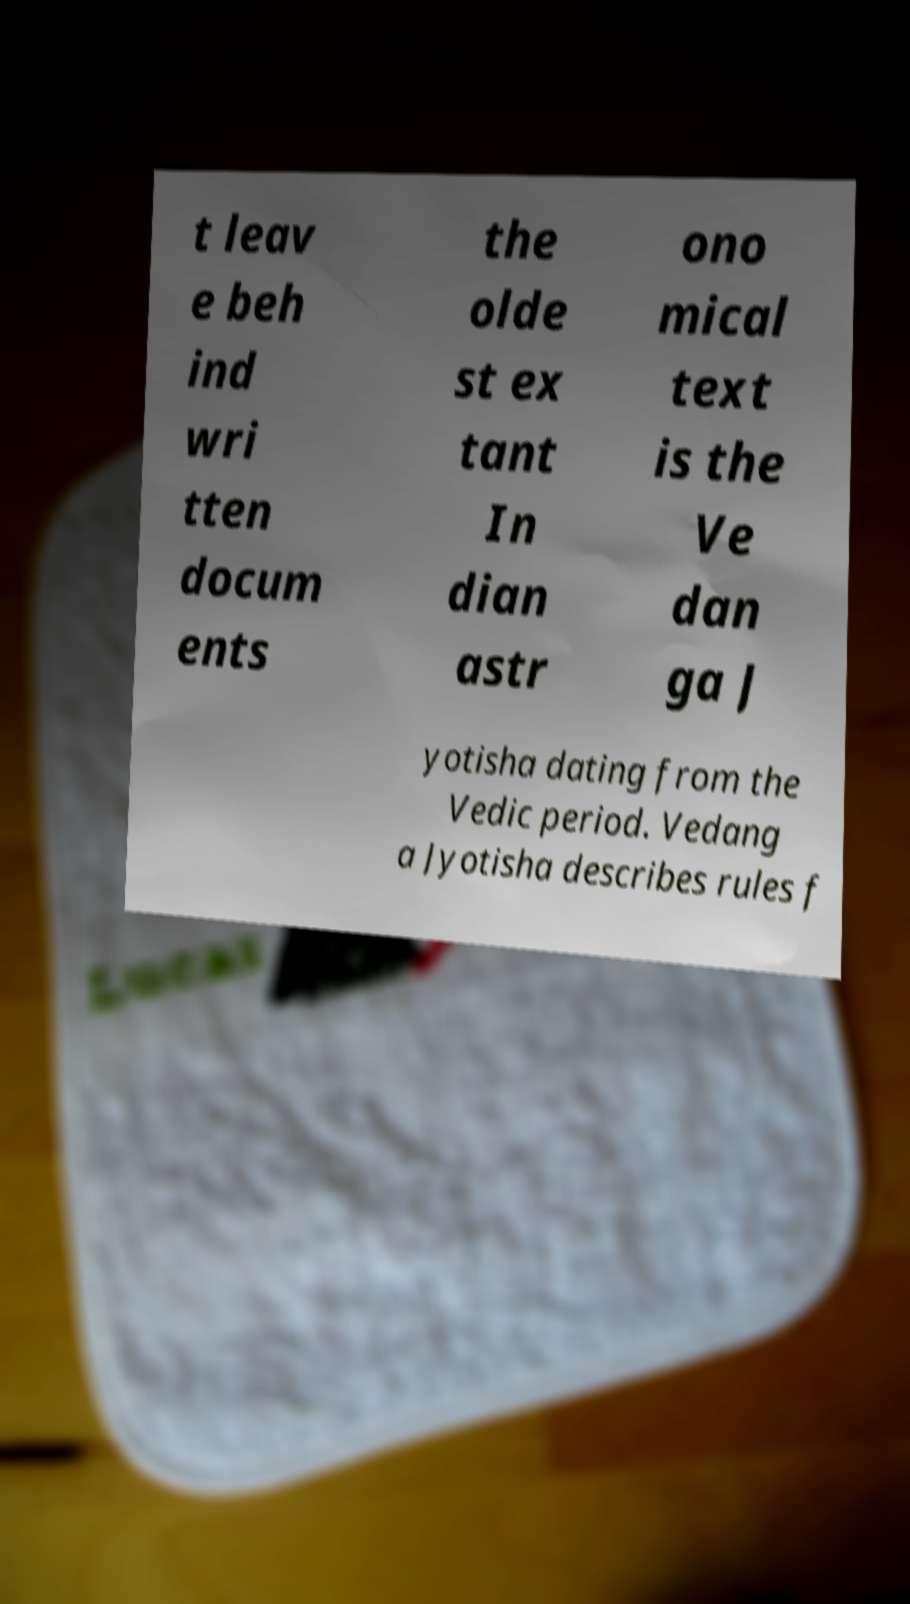Please read and relay the text visible in this image. What does it say? t leav e beh ind wri tten docum ents the olde st ex tant In dian astr ono mical text is the Ve dan ga J yotisha dating from the Vedic period. Vedang a Jyotisha describes rules f 